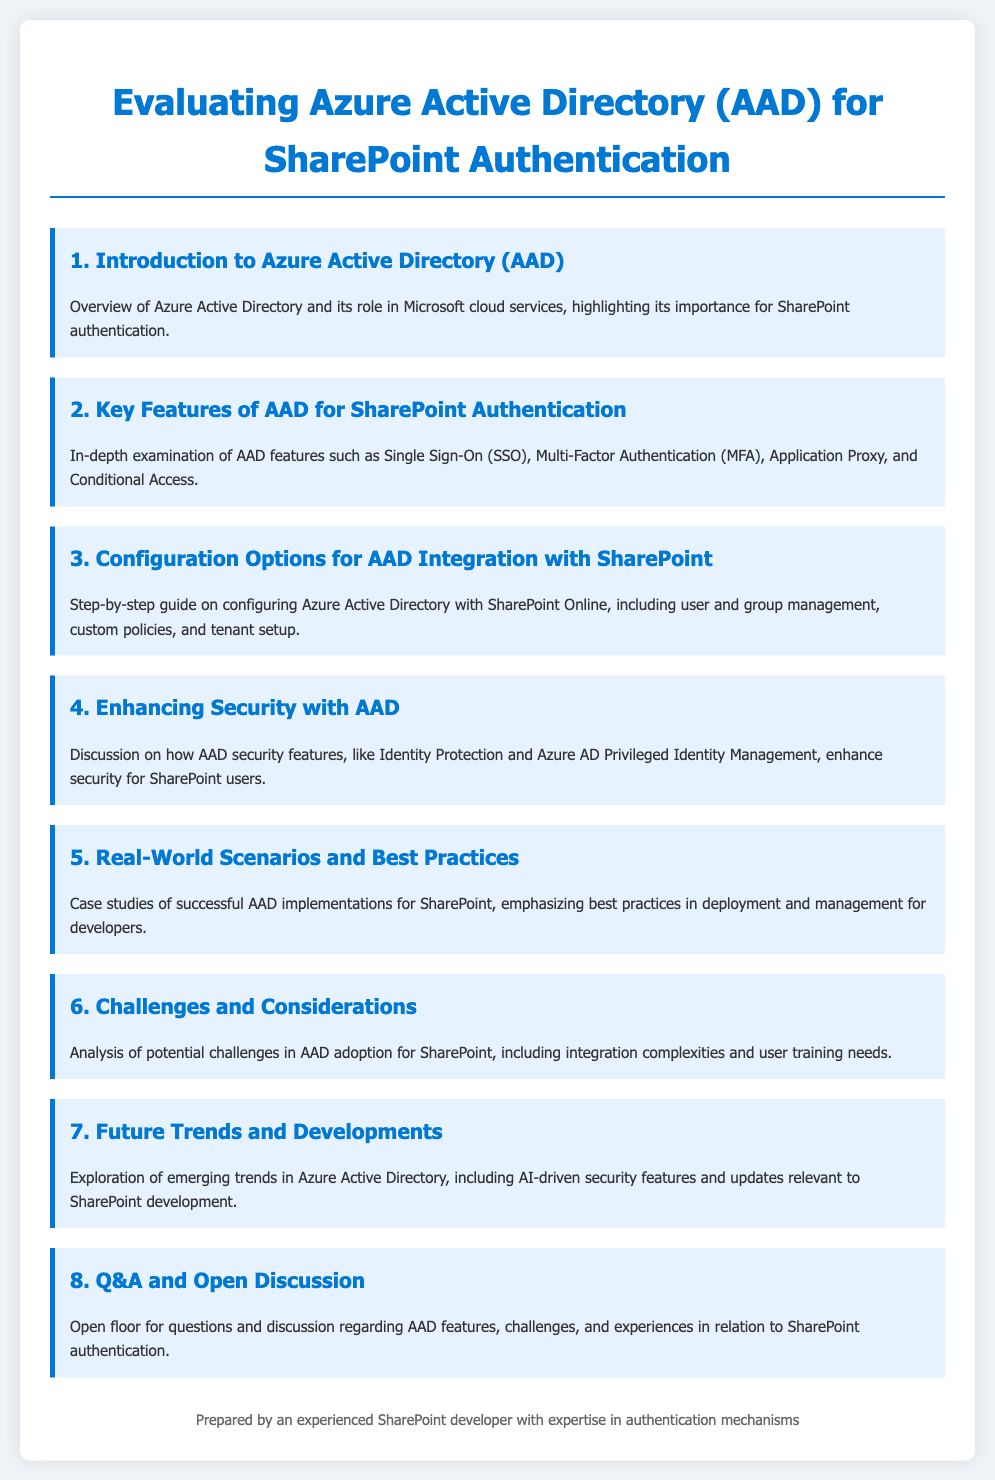What is the title of the agenda? The title of the agenda is clearly stated at the top of the document.
Answer: Evaluating Azure Active Directory (AAD) for SharePoint Authentication How many key features of AAD for SharePoint Authentication are examined? The document specifies a section dedicated to AAD features, implying multiple features are covered.
Answer: 4 What security feature enhances SharePoint user security? The document lists AAD security features aimed at enhancing security for SharePoint users.
Answer: Identity Protection What is discussed in the fourth agenda item? The document mentions discussions related to AAD security features in the specific agenda section.
Answer: Enhancing Security with AAD Which agenda item covers real-world implementation case studies? The agenda item explicitly focuses on case studies illustrating AAD's applications in a practical context.
Answer: 5. Real-World Scenarios and Best Practices What does the last agenda item invite? The last item encourages participation and dialogue on a specified topic in AAD and SharePoint.
Answer: Q&A and Open Discussion What type of authentication does AAD provide? The document indicates that AAD offers a specific type of authentication feature.
Answer: Single Sign-On (SSO) What is a challenge in AAD adoption for SharePoint? The document identifies potential obstacles in AAD adoption, particularly in relation to training.
Answer: User training needs 